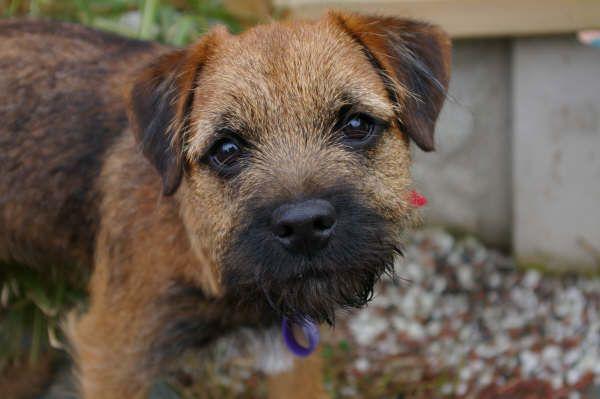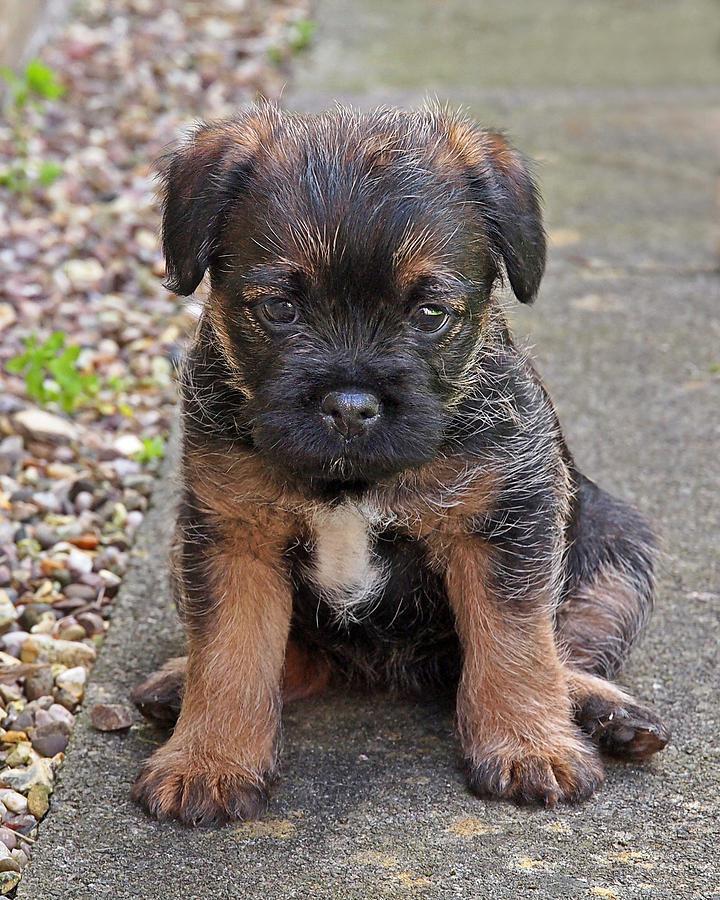The first image is the image on the left, the second image is the image on the right. For the images displayed, is the sentence "A collar is visible around the neck of the dog in the right image." factually correct? Answer yes or no. No. 